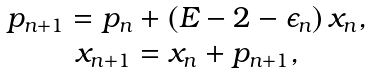Convert formula to latex. <formula><loc_0><loc_0><loc_500><loc_500>\begin{array} { c } p _ { n + 1 } = p _ { n } + ( E - 2 - \epsilon _ { n } ) \, x _ { n } , \\ x _ { n + 1 } = x _ { n } + p _ { n + 1 } , \end{array}</formula> 